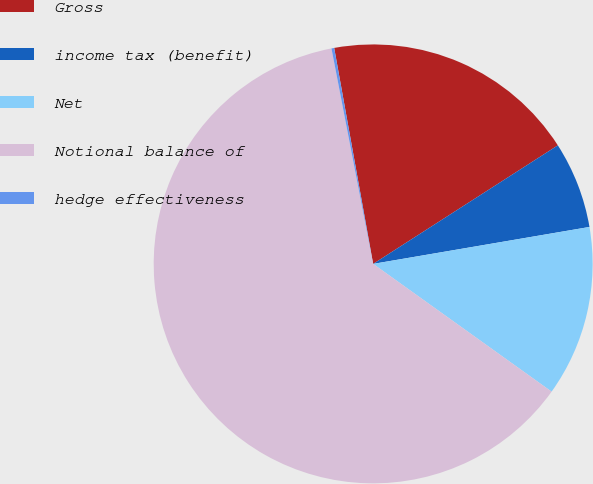Convert chart to OTSL. <chart><loc_0><loc_0><loc_500><loc_500><pie_chart><fcel>Gross<fcel>income tax (benefit)<fcel>Net<fcel>Notional balance of<fcel>hedge effectiveness<nl><fcel>18.76%<fcel>6.39%<fcel>12.58%<fcel>62.07%<fcel>0.2%<nl></chart> 